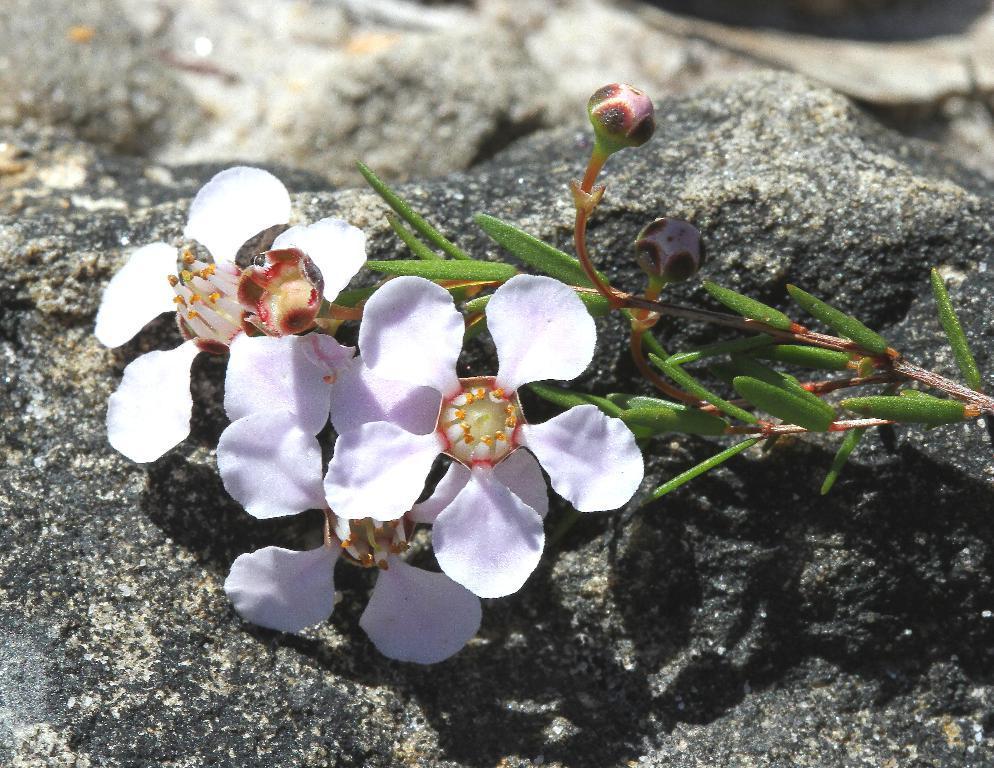Describe this image in one or two sentences. In this picture I can see flowers, buds and leaves on the rock, and there is blur background. 